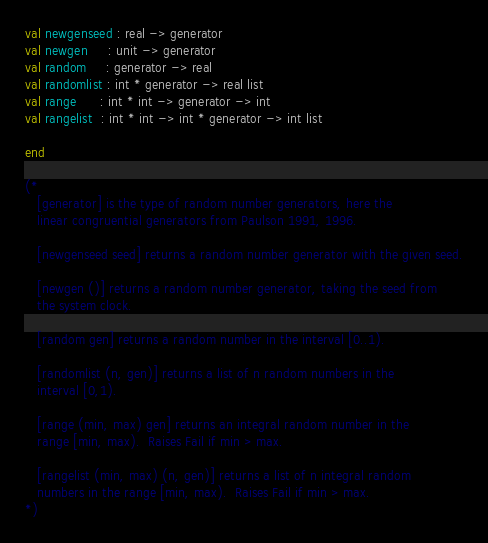<code> <loc_0><loc_0><loc_500><loc_500><_SML_>val newgenseed : real -> generator
val newgen     : unit -> generator
val random     : generator -> real
val randomlist : int * generator -> real list
val range      : int * int -> generator -> int
val rangelist  : int * int -> int * generator -> int list

end

(*
   [generator] is the type of random number generators, here the
   linear congruential generators from Paulson 1991, 1996.

   [newgenseed seed] returns a random number generator with the given seed.

   [newgen ()] returns a random number generator, taking the seed from
   the system clock.

   [random gen] returns a random number in the interval [0..1).

   [randomlist (n, gen)] returns a list of n random numbers in the
   interval [0,1).

   [range (min, max) gen] returns an integral random number in the
   range [min, max).  Raises Fail if min > max.

   [rangelist (min, max) (n, gen)] returns a list of n integral random
   numbers in the range [min, max).  Raises Fail if min > max.
*)
</code> 